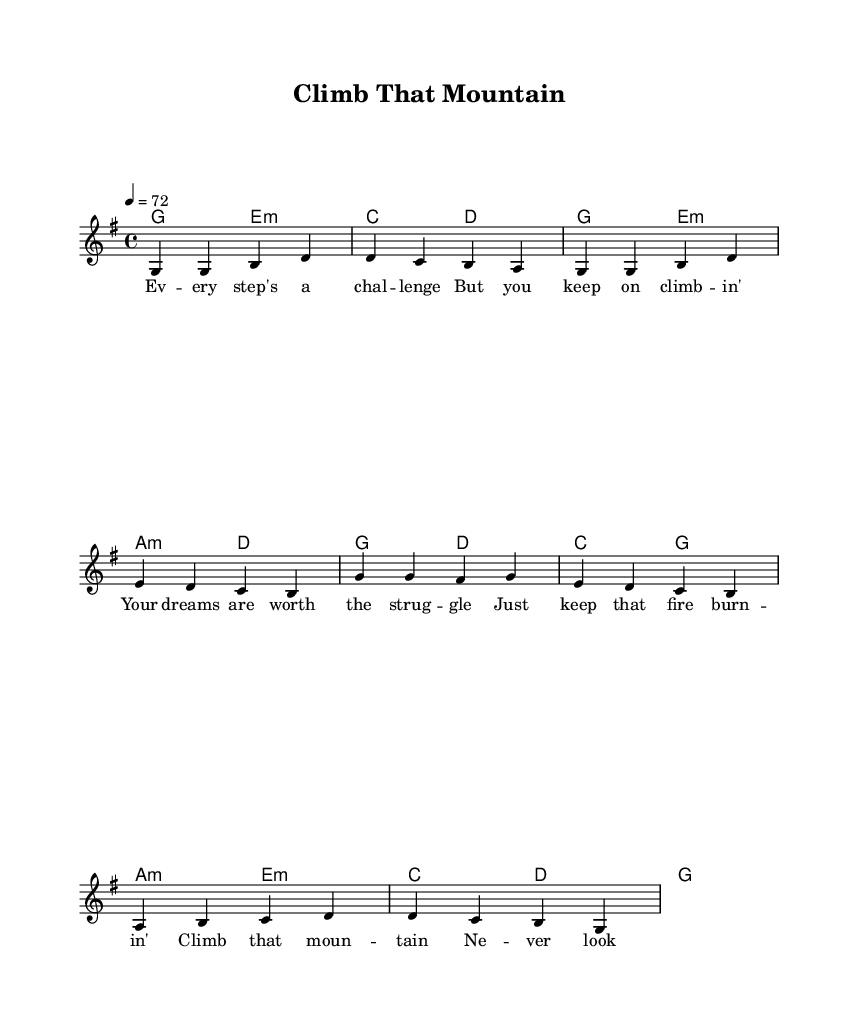What is the key signature of this music? The key signature is G major, which has one sharp (F#). You can identify this by looking at the beginning of the staff where the sharp is indicated.
Answer: G major What is the time signature of this music? The time signature is 4/4, meaning there are four beats in a measure, and a quarter note receives one beat. This can be found at the beginning of the piece, where the time signature is noted.
Answer: 4/4 What is the tempo marking for this piece? The tempo marking indicates a speed of 72 beats per minute, specifically noted as "4 = 72." This can be observed in the tempo instruction near the beginning of the score.
Answer: 72 How many measures are in the verse? The verse consists of four measures, which can be seen by counting the groups of notes separated by vertical lines (bar lines) in the verse section of the score.
Answer: 4 What is the last chord in the chorus? The last chord in the chorus is G major, as indicated by the chord above the last measure of the chorus segment in the chord mode section of the score.
Answer: G Identify the emotional theme expressed in the lyrics. The lyrics focus on perseverance and determination, promoting the idea of continuing to pursue one's dreams despite challenges. This thematic element can be inferred from the content of the lyrics accompanying the music.
Answer: Perseverance What is the main melodic note of the chorus? The main melodic note in the chorus is G, as it is repeated multiple times and forms the foundational note of the melody. This can be identified by looking at the pitch notation in the chorus part.
Answer: G 